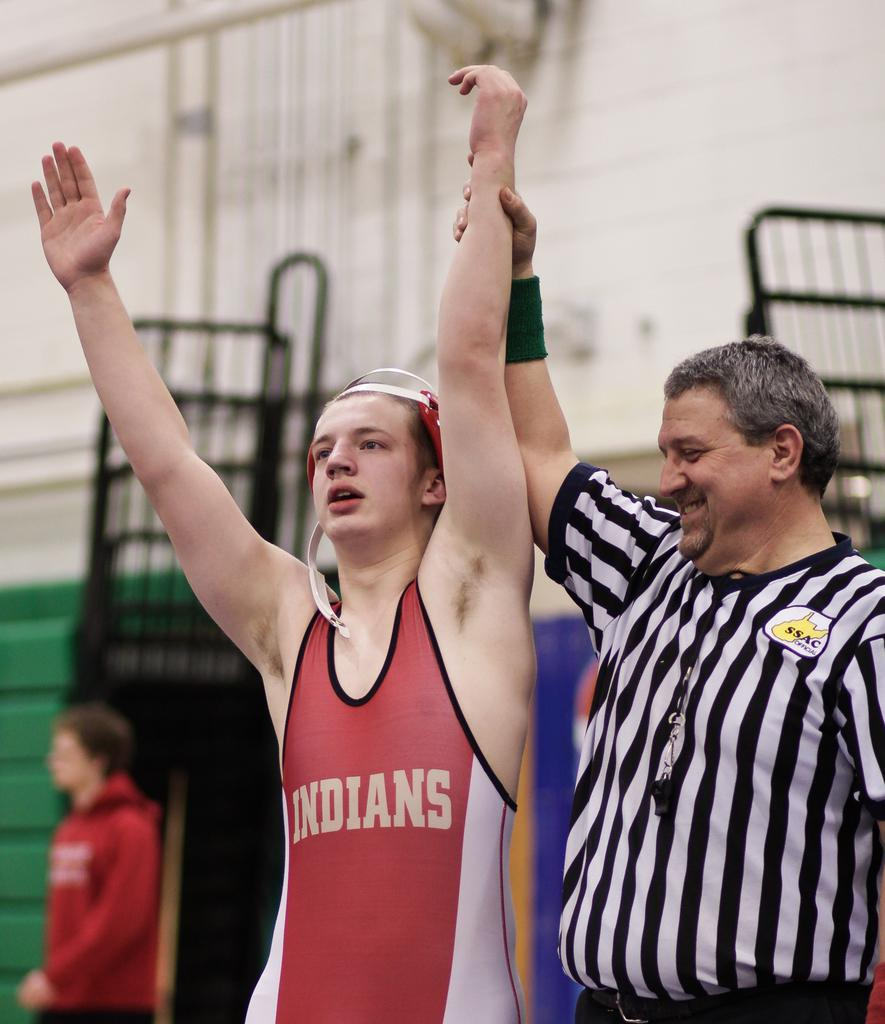<image>
Summarize the visual content of the image. the name Indians is on the red and white item 